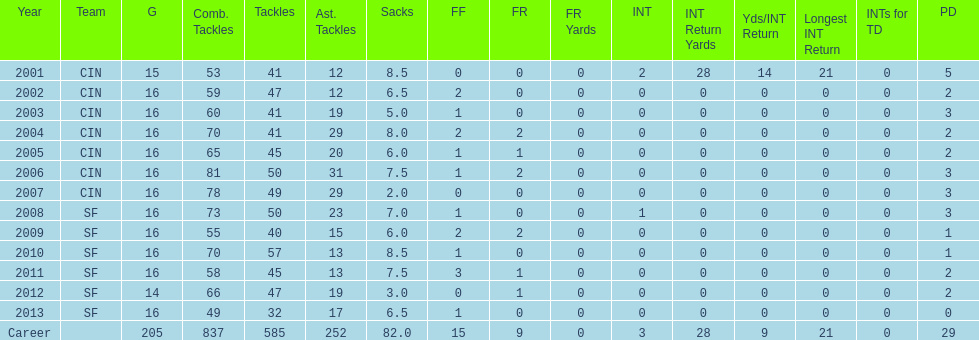How many consecutive seasons has he played sixteen games? 10. 